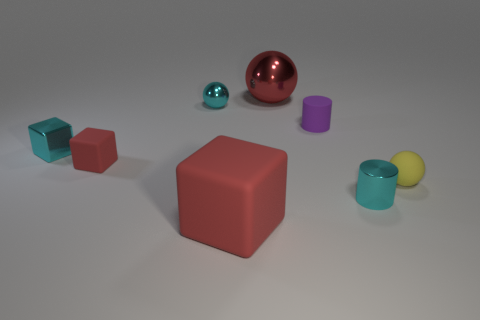Add 2 big balls. How many objects exist? 10 Subtract all cubes. How many objects are left? 5 Subtract 0 yellow cubes. How many objects are left? 8 Subtract all big purple spheres. Subtract all cyan cubes. How many objects are left? 7 Add 2 small matte cubes. How many small matte cubes are left? 3 Add 4 small balls. How many small balls exist? 6 